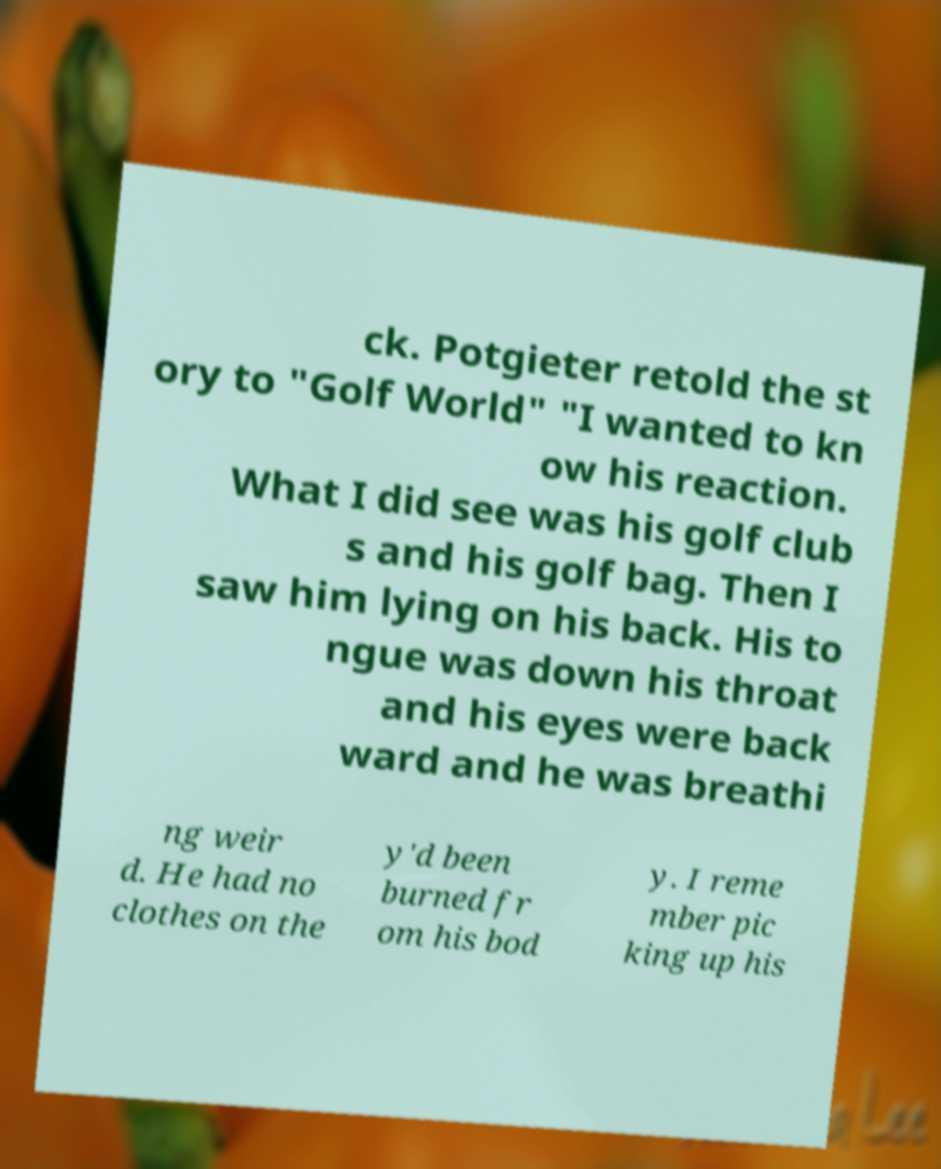Can you accurately transcribe the text from the provided image for me? ck. Potgieter retold the st ory to "Golf World" "I wanted to kn ow his reaction. What I did see was his golf club s and his golf bag. Then I saw him lying on his back. His to ngue was down his throat and his eyes were back ward and he was breathi ng weir d. He had no clothes on the y'd been burned fr om his bod y. I reme mber pic king up his 